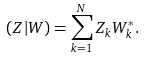<formula> <loc_0><loc_0><loc_500><loc_500>( Z | W ) = \sum _ { k = 1 } ^ { N } Z _ { k } W ^ { * } _ { k } .</formula> 